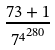Convert formula to latex. <formula><loc_0><loc_0><loc_500><loc_500>\frac { 7 3 + 1 } { { 7 ^ { 4 } } ^ { 2 8 0 } }</formula> 